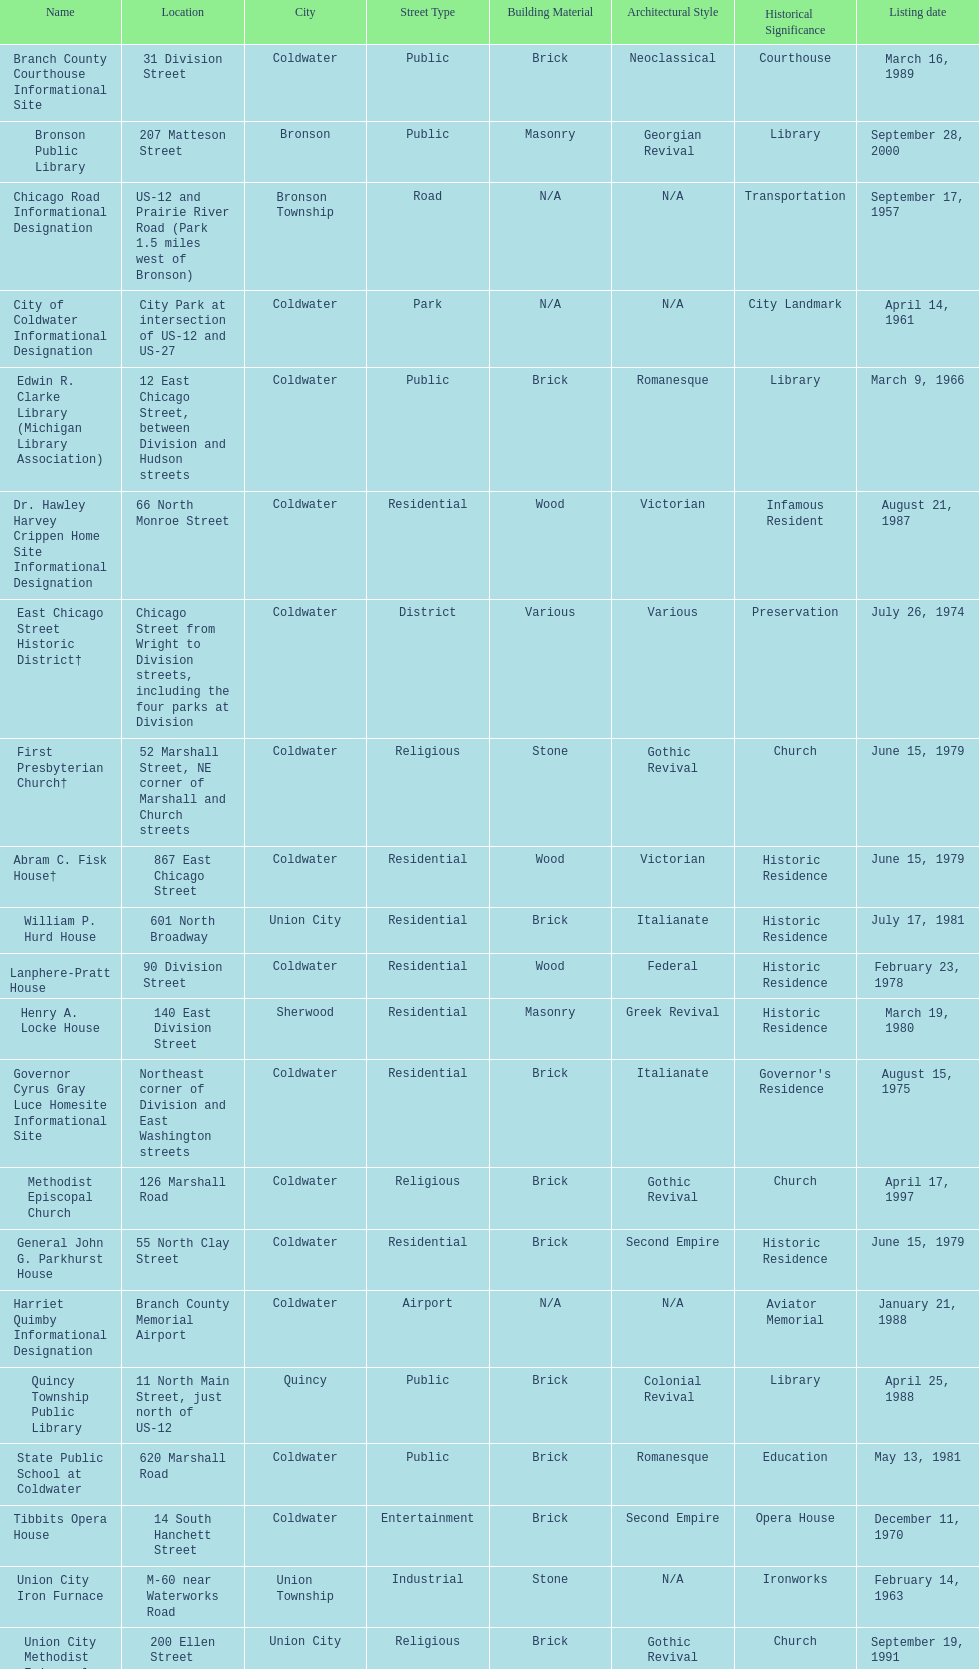How many years passed between the historic listing of public libraries in quincy and bronson? 12. 